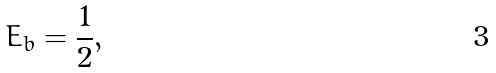<formula> <loc_0><loc_0><loc_500><loc_500>E _ { b } = \frac { 1 } { 2 } ,</formula> 